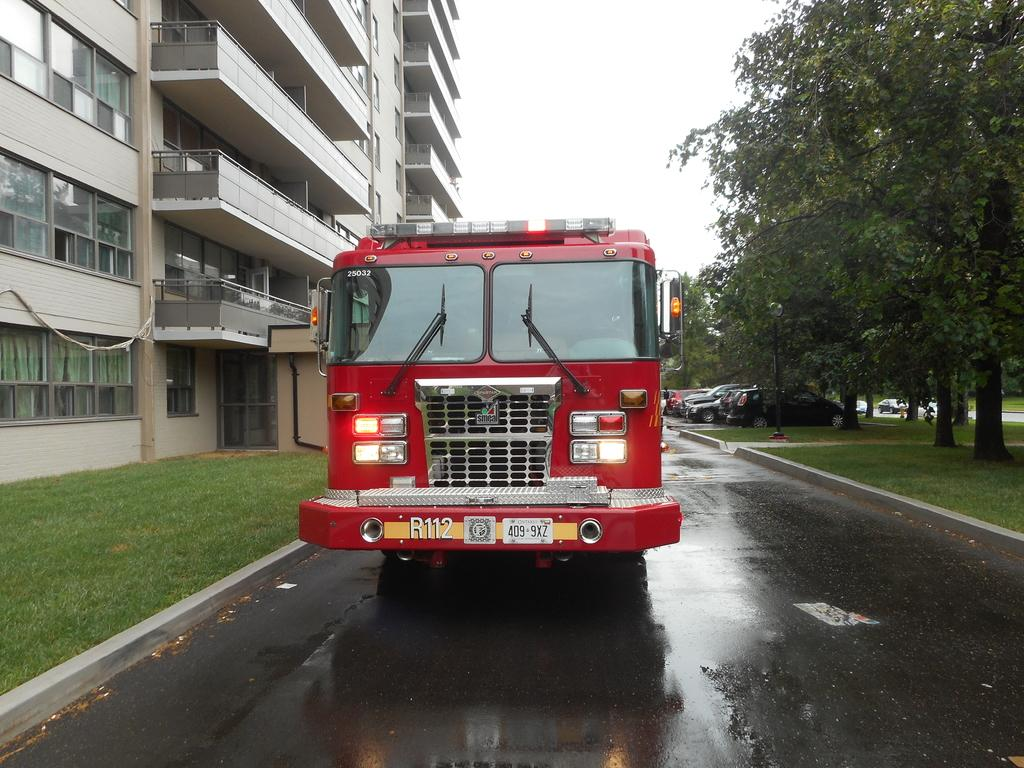What can be seen on the road in the image? There are vehicles on the road in the image. What is located beside the vehicles? Trees, grass, and a building are located beside the vehicles. What type of windows are visible in the image? There are glass windows visible in the image. How many babies are celebrating their birthday in the image? There are no babies or birthday celebrations present in the image. What type of duck can be seen swimming in the water in the image? There is no duck or water present in the image. 